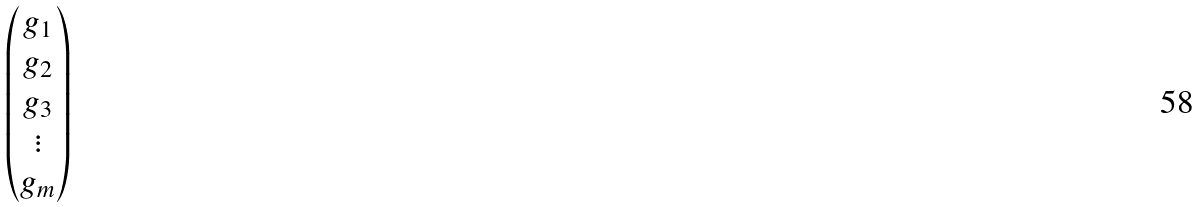<formula> <loc_0><loc_0><loc_500><loc_500>\begin{pmatrix} g _ { 1 } \\ g _ { 2 } \\ g _ { 3 } \\ \vdots \\ g _ { m } \end{pmatrix}</formula> 